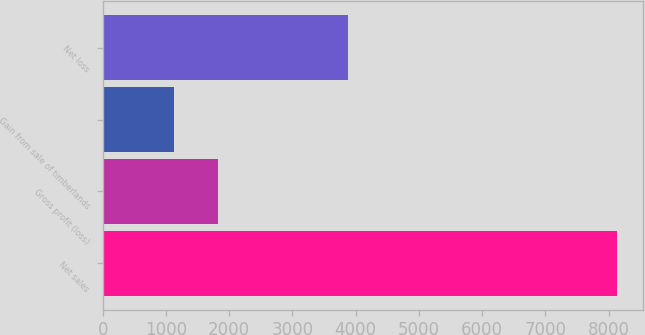Convert chart to OTSL. <chart><loc_0><loc_0><loc_500><loc_500><bar_chart><fcel>Net sales<fcel>Gross profit (loss)<fcel>Gain from sale of timberlands<fcel>Net loss<nl><fcel>8134<fcel>1825.9<fcel>1125<fcel>3876<nl></chart> 